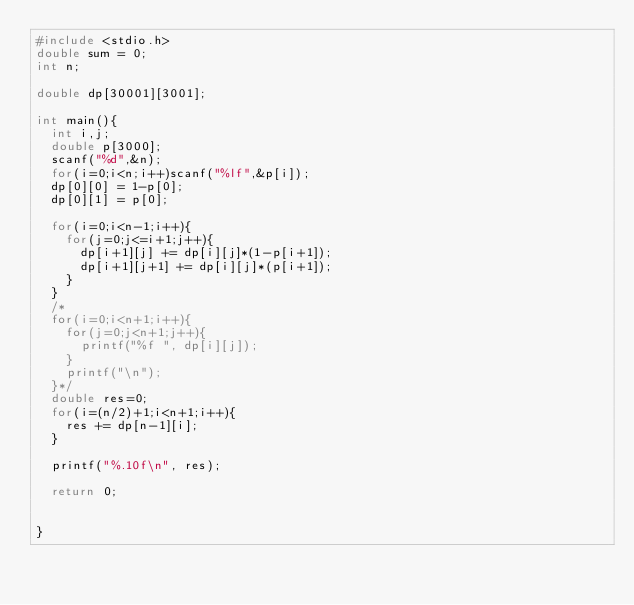Convert code to text. <code><loc_0><loc_0><loc_500><loc_500><_C_>#include <stdio.h>
double sum = 0;
int n;

double dp[30001][3001];

int main(){
  int i,j;
  double p[3000];
  scanf("%d",&n);
  for(i=0;i<n;i++)scanf("%lf",&p[i]);
  dp[0][0] = 1-p[0];
  dp[0][1] = p[0];

  for(i=0;i<n-1;i++){
    for(j=0;j<=i+1;j++){
      dp[i+1][j] += dp[i][j]*(1-p[i+1]);
      dp[i+1][j+1] += dp[i][j]*(p[i+1]);
    }
  }
  /*
  for(i=0;i<n+1;i++){
    for(j=0;j<n+1;j++){
      printf("%f ", dp[i][j]);
    }
    printf("\n");
  }*/
  double res=0;
  for(i=(n/2)+1;i<n+1;i++){
    res += dp[n-1][i];
  }

  printf("%.10f\n", res);

  return 0;


}
</code> 